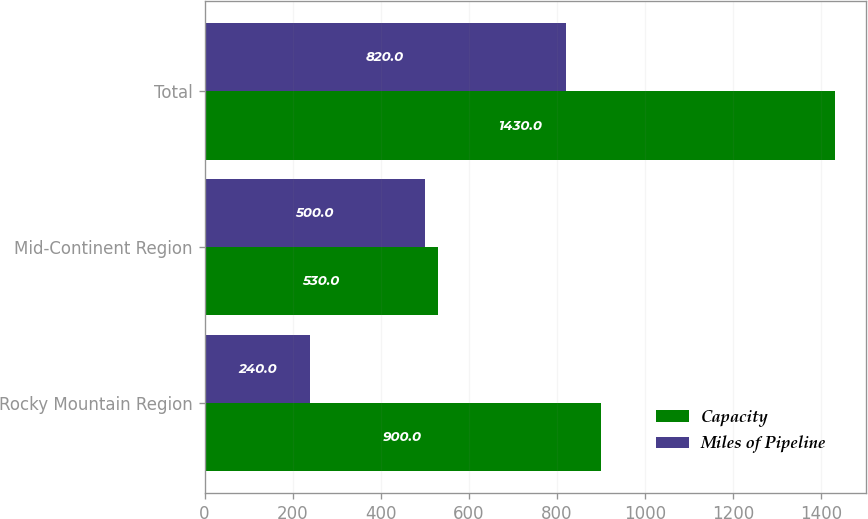Convert chart. <chart><loc_0><loc_0><loc_500><loc_500><stacked_bar_chart><ecel><fcel>Rocky Mountain Region<fcel>Mid-Continent Region<fcel>Total<nl><fcel>Capacity<fcel>900<fcel>530<fcel>1430<nl><fcel>Miles of Pipeline<fcel>240<fcel>500<fcel>820<nl></chart> 